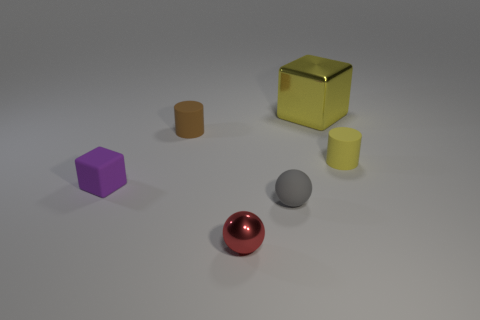Subtract 1 cylinders. How many cylinders are left? 1 Add 1 big yellow shiny spheres. How many objects exist? 7 Subtract all balls. How many objects are left? 4 Add 2 large red metal blocks. How many large red metal blocks exist? 2 Subtract 1 gray spheres. How many objects are left? 5 Subtract all large cyan metal cylinders. Subtract all yellow things. How many objects are left? 4 Add 4 yellow shiny blocks. How many yellow shiny blocks are left? 5 